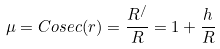Convert formula to latex. <formula><loc_0><loc_0><loc_500><loc_500>\mu = C o s e c ( r ) = \frac { R ^ { / } } { R } = 1 + \frac { h } { R }</formula> 